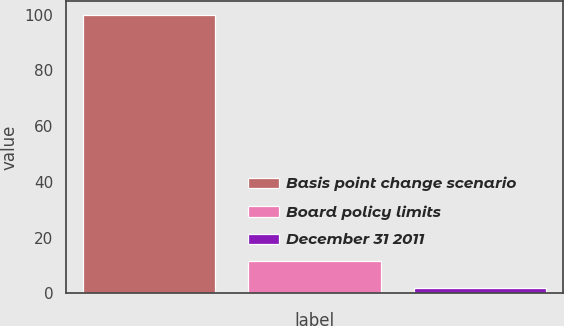Convert chart to OTSL. <chart><loc_0><loc_0><loc_500><loc_500><bar_chart><fcel>Basis point change scenario<fcel>Board policy limits<fcel>December 31 2011<nl><fcel>100<fcel>11.62<fcel>1.8<nl></chart> 